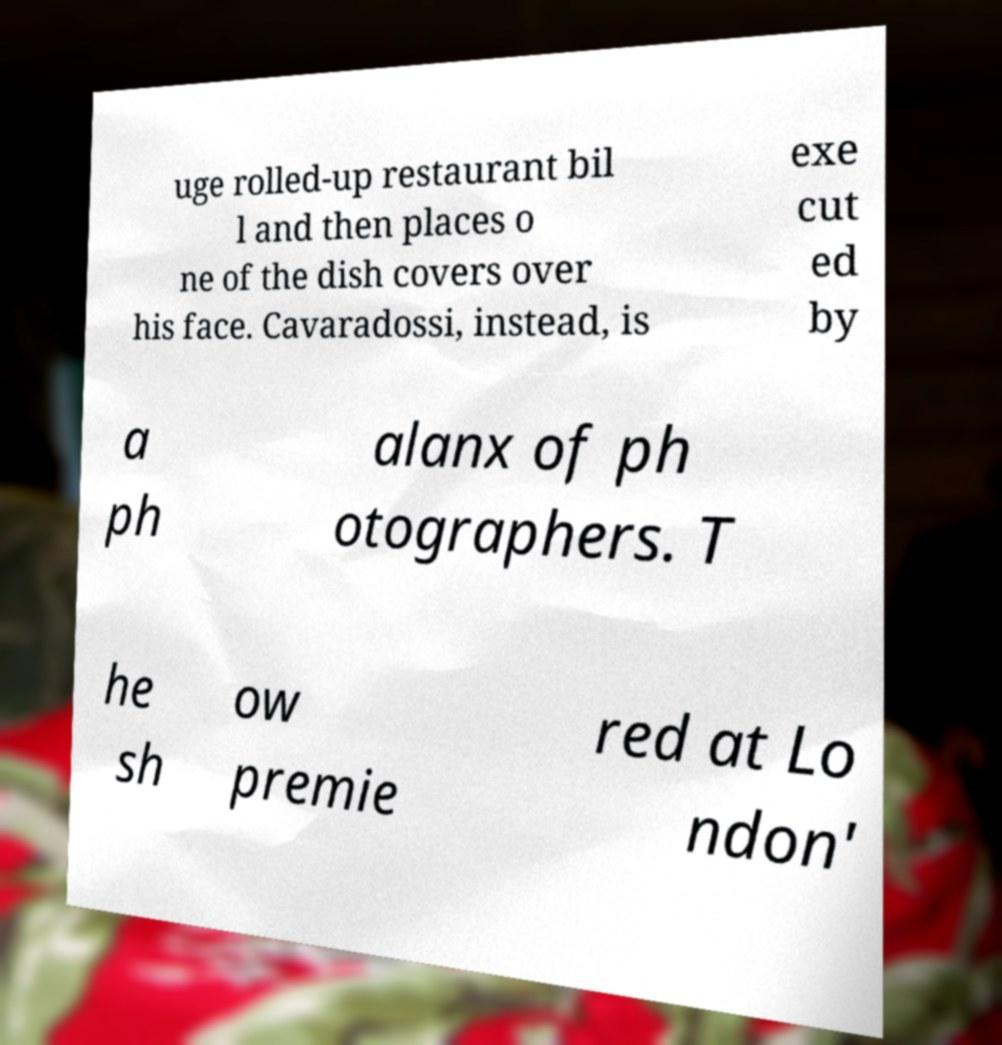Could you extract and type out the text from this image? uge rolled-up restaurant bil l and then places o ne of the dish covers over his face. Cavaradossi, instead, is exe cut ed by a ph alanx of ph otographers. T he sh ow premie red at Lo ndon' 